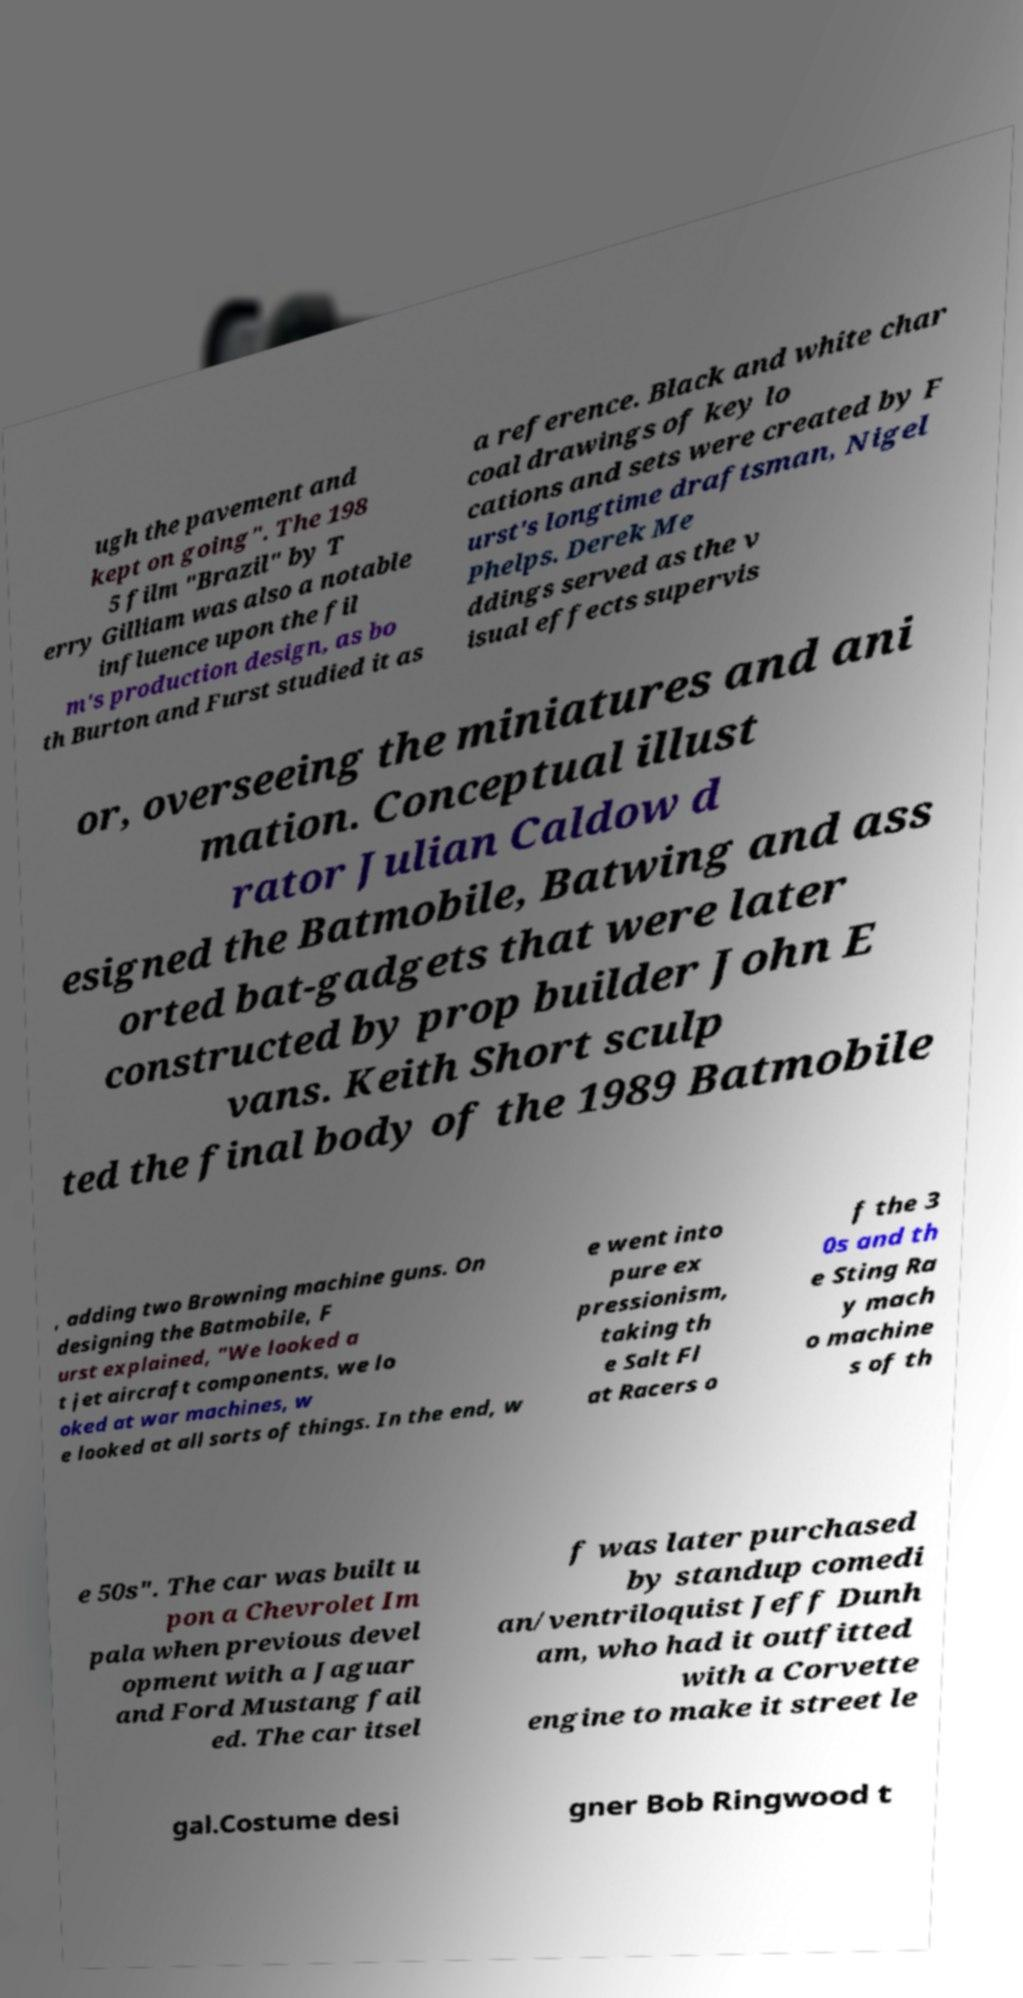For documentation purposes, I need the text within this image transcribed. Could you provide that? ugh the pavement and kept on going". The 198 5 film "Brazil" by T erry Gilliam was also a notable influence upon the fil m's production design, as bo th Burton and Furst studied it as a reference. Black and white char coal drawings of key lo cations and sets were created by F urst's longtime draftsman, Nigel Phelps. Derek Me ddings served as the v isual effects supervis or, overseeing the miniatures and ani mation. Conceptual illust rator Julian Caldow d esigned the Batmobile, Batwing and ass orted bat-gadgets that were later constructed by prop builder John E vans. Keith Short sculp ted the final body of the 1989 Batmobile , adding two Browning machine guns. On designing the Batmobile, F urst explained, "We looked a t jet aircraft components, we lo oked at war machines, w e looked at all sorts of things. In the end, w e went into pure ex pressionism, taking th e Salt Fl at Racers o f the 3 0s and th e Sting Ra y mach o machine s of th e 50s". The car was built u pon a Chevrolet Im pala when previous devel opment with a Jaguar and Ford Mustang fail ed. The car itsel f was later purchased by standup comedi an/ventriloquist Jeff Dunh am, who had it outfitted with a Corvette engine to make it street le gal.Costume desi gner Bob Ringwood t 